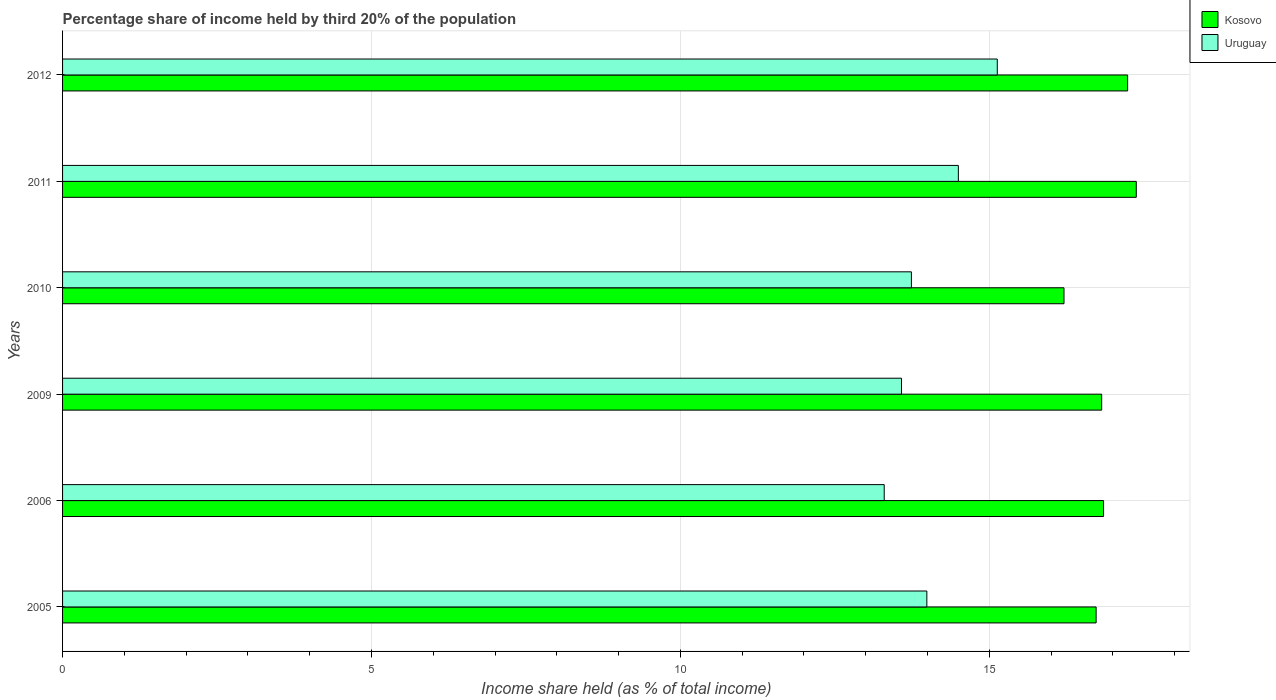How many groups of bars are there?
Provide a short and direct response. 6. Are the number of bars on each tick of the Y-axis equal?
Keep it short and to the point. Yes. How many bars are there on the 4th tick from the top?
Provide a short and direct response. 2. How many bars are there on the 4th tick from the bottom?
Your response must be concise. 2. In how many cases, is the number of bars for a given year not equal to the number of legend labels?
Offer a terse response. 0. Across all years, what is the maximum share of income held by third 20% of the population in Kosovo?
Your answer should be compact. 17.38. Across all years, what is the minimum share of income held by third 20% of the population in Uruguay?
Offer a very short reply. 13.3. In which year was the share of income held by third 20% of the population in Uruguay minimum?
Provide a succinct answer. 2006. What is the total share of income held by third 20% of the population in Uruguay in the graph?
Give a very brief answer. 84.24. What is the difference between the share of income held by third 20% of the population in Kosovo in 2005 and that in 2009?
Your answer should be compact. -0.09. What is the difference between the share of income held by third 20% of the population in Uruguay in 2005 and the share of income held by third 20% of the population in Kosovo in 2012?
Your response must be concise. -3.25. What is the average share of income held by third 20% of the population in Uruguay per year?
Provide a succinct answer. 14.04. In the year 2009, what is the difference between the share of income held by third 20% of the population in Kosovo and share of income held by third 20% of the population in Uruguay?
Provide a succinct answer. 3.24. What is the ratio of the share of income held by third 20% of the population in Uruguay in 2005 to that in 2006?
Provide a short and direct response. 1.05. What is the difference between the highest and the second highest share of income held by third 20% of the population in Kosovo?
Offer a very short reply. 0.14. What is the difference between the highest and the lowest share of income held by third 20% of the population in Uruguay?
Provide a succinct answer. 1.83. Is the sum of the share of income held by third 20% of the population in Kosovo in 2006 and 2011 greater than the maximum share of income held by third 20% of the population in Uruguay across all years?
Your answer should be very brief. Yes. What does the 1st bar from the top in 2005 represents?
Your response must be concise. Uruguay. What does the 1st bar from the bottom in 2006 represents?
Provide a succinct answer. Kosovo. How many bars are there?
Offer a terse response. 12. Are the values on the major ticks of X-axis written in scientific E-notation?
Provide a succinct answer. No. Does the graph contain grids?
Offer a terse response. Yes. How are the legend labels stacked?
Your answer should be very brief. Vertical. What is the title of the graph?
Offer a very short reply. Percentage share of income held by third 20% of the population. Does "High income" appear as one of the legend labels in the graph?
Provide a short and direct response. No. What is the label or title of the X-axis?
Your response must be concise. Income share held (as % of total income). What is the label or title of the Y-axis?
Provide a succinct answer. Years. What is the Income share held (as % of total income) of Kosovo in 2005?
Your answer should be very brief. 16.73. What is the Income share held (as % of total income) in Uruguay in 2005?
Your answer should be very brief. 13.99. What is the Income share held (as % of total income) of Kosovo in 2006?
Give a very brief answer. 16.85. What is the Income share held (as % of total income) in Kosovo in 2009?
Provide a succinct answer. 16.82. What is the Income share held (as % of total income) in Uruguay in 2009?
Give a very brief answer. 13.58. What is the Income share held (as % of total income) of Kosovo in 2010?
Give a very brief answer. 16.21. What is the Income share held (as % of total income) of Uruguay in 2010?
Keep it short and to the point. 13.74. What is the Income share held (as % of total income) of Kosovo in 2011?
Provide a succinct answer. 17.38. What is the Income share held (as % of total income) of Uruguay in 2011?
Provide a succinct answer. 14.5. What is the Income share held (as % of total income) of Kosovo in 2012?
Offer a terse response. 17.24. What is the Income share held (as % of total income) in Uruguay in 2012?
Your answer should be very brief. 15.13. Across all years, what is the maximum Income share held (as % of total income) of Kosovo?
Your answer should be very brief. 17.38. Across all years, what is the maximum Income share held (as % of total income) of Uruguay?
Provide a succinct answer. 15.13. Across all years, what is the minimum Income share held (as % of total income) of Kosovo?
Your response must be concise. 16.21. Across all years, what is the minimum Income share held (as % of total income) in Uruguay?
Ensure brevity in your answer.  13.3. What is the total Income share held (as % of total income) of Kosovo in the graph?
Give a very brief answer. 101.23. What is the total Income share held (as % of total income) of Uruguay in the graph?
Your response must be concise. 84.24. What is the difference between the Income share held (as % of total income) of Kosovo in 2005 and that in 2006?
Make the answer very short. -0.12. What is the difference between the Income share held (as % of total income) of Uruguay in 2005 and that in 2006?
Give a very brief answer. 0.69. What is the difference between the Income share held (as % of total income) of Kosovo in 2005 and that in 2009?
Give a very brief answer. -0.09. What is the difference between the Income share held (as % of total income) of Uruguay in 2005 and that in 2009?
Keep it short and to the point. 0.41. What is the difference between the Income share held (as % of total income) in Kosovo in 2005 and that in 2010?
Give a very brief answer. 0.52. What is the difference between the Income share held (as % of total income) of Uruguay in 2005 and that in 2010?
Offer a terse response. 0.25. What is the difference between the Income share held (as % of total income) in Kosovo in 2005 and that in 2011?
Keep it short and to the point. -0.65. What is the difference between the Income share held (as % of total income) of Uruguay in 2005 and that in 2011?
Offer a terse response. -0.51. What is the difference between the Income share held (as % of total income) of Kosovo in 2005 and that in 2012?
Ensure brevity in your answer.  -0.51. What is the difference between the Income share held (as % of total income) of Uruguay in 2005 and that in 2012?
Keep it short and to the point. -1.14. What is the difference between the Income share held (as % of total income) in Kosovo in 2006 and that in 2009?
Offer a very short reply. 0.03. What is the difference between the Income share held (as % of total income) of Uruguay in 2006 and that in 2009?
Your response must be concise. -0.28. What is the difference between the Income share held (as % of total income) in Kosovo in 2006 and that in 2010?
Provide a succinct answer. 0.64. What is the difference between the Income share held (as % of total income) of Uruguay in 2006 and that in 2010?
Offer a very short reply. -0.44. What is the difference between the Income share held (as % of total income) in Kosovo in 2006 and that in 2011?
Offer a terse response. -0.53. What is the difference between the Income share held (as % of total income) of Uruguay in 2006 and that in 2011?
Make the answer very short. -1.2. What is the difference between the Income share held (as % of total income) in Kosovo in 2006 and that in 2012?
Offer a terse response. -0.39. What is the difference between the Income share held (as % of total income) in Uruguay in 2006 and that in 2012?
Keep it short and to the point. -1.83. What is the difference between the Income share held (as % of total income) in Kosovo in 2009 and that in 2010?
Provide a short and direct response. 0.61. What is the difference between the Income share held (as % of total income) in Uruguay in 2009 and that in 2010?
Your answer should be very brief. -0.16. What is the difference between the Income share held (as % of total income) of Kosovo in 2009 and that in 2011?
Offer a very short reply. -0.56. What is the difference between the Income share held (as % of total income) of Uruguay in 2009 and that in 2011?
Offer a terse response. -0.92. What is the difference between the Income share held (as % of total income) of Kosovo in 2009 and that in 2012?
Your response must be concise. -0.42. What is the difference between the Income share held (as % of total income) of Uruguay in 2009 and that in 2012?
Your response must be concise. -1.55. What is the difference between the Income share held (as % of total income) in Kosovo in 2010 and that in 2011?
Your answer should be very brief. -1.17. What is the difference between the Income share held (as % of total income) of Uruguay in 2010 and that in 2011?
Your response must be concise. -0.76. What is the difference between the Income share held (as % of total income) in Kosovo in 2010 and that in 2012?
Your answer should be very brief. -1.03. What is the difference between the Income share held (as % of total income) in Uruguay in 2010 and that in 2012?
Your answer should be compact. -1.39. What is the difference between the Income share held (as % of total income) in Kosovo in 2011 and that in 2012?
Your response must be concise. 0.14. What is the difference between the Income share held (as % of total income) in Uruguay in 2011 and that in 2012?
Keep it short and to the point. -0.63. What is the difference between the Income share held (as % of total income) in Kosovo in 2005 and the Income share held (as % of total income) in Uruguay in 2006?
Provide a succinct answer. 3.43. What is the difference between the Income share held (as % of total income) of Kosovo in 2005 and the Income share held (as % of total income) of Uruguay in 2009?
Provide a succinct answer. 3.15. What is the difference between the Income share held (as % of total income) in Kosovo in 2005 and the Income share held (as % of total income) in Uruguay in 2010?
Your answer should be very brief. 2.99. What is the difference between the Income share held (as % of total income) of Kosovo in 2005 and the Income share held (as % of total income) of Uruguay in 2011?
Offer a terse response. 2.23. What is the difference between the Income share held (as % of total income) in Kosovo in 2006 and the Income share held (as % of total income) in Uruguay in 2009?
Keep it short and to the point. 3.27. What is the difference between the Income share held (as % of total income) of Kosovo in 2006 and the Income share held (as % of total income) of Uruguay in 2010?
Provide a succinct answer. 3.11. What is the difference between the Income share held (as % of total income) of Kosovo in 2006 and the Income share held (as % of total income) of Uruguay in 2011?
Provide a succinct answer. 2.35. What is the difference between the Income share held (as % of total income) in Kosovo in 2006 and the Income share held (as % of total income) in Uruguay in 2012?
Keep it short and to the point. 1.72. What is the difference between the Income share held (as % of total income) in Kosovo in 2009 and the Income share held (as % of total income) in Uruguay in 2010?
Provide a succinct answer. 3.08. What is the difference between the Income share held (as % of total income) of Kosovo in 2009 and the Income share held (as % of total income) of Uruguay in 2011?
Offer a very short reply. 2.32. What is the difference between the Income share held (as % of total income) of Kosovo in 2009 and the Income share held (as % of total income) of Uruguay in 2012?
Your response must be concise. 1.69. What is the difference between the Income share held (as % of total income) of Kosovo in 2010 and the Income share held (as % of total income) of Uruguay in 2011?
Provide a short and direct response. 1.71. What is the difference between the Income share held (as % of total income) of Kosovo in 2011 and the Income share held (as % of total income) of Uruguay in 2012?
Ensure brevity in your answer.  2.25. What is the average Income share held (as % of total income) of Kosovo per year?
Offer a terse response. 16.87. What is the average Income share held (as % of total income) in Uruguay per year?
Your answer should be very brief. 14.04. In the year 2005, what is the difference between the Income share held (as % of total income) of Kosovo and Income share held (as % of total income) of Uruguay?
Your response must be concise. 2.74. In the year 2006, what is the difference between the Income share held (as % of total income) in Kosovo and Income share held (as % of total income) in Uruguay?
Keep it short and to the point. 3.55. In the year 2009, what is the difference between the Income share held (as % of total income) in Kosovo and Income share held (as % of total income) in Uruguay?
Keep it short and to the point. 3.24. In the year 2010, what is the difference between the Income share held (as % of total income) of Kosovo and Income share held (as % of total income) of Uruguay?
Your answer should be compact. 2.47. In the year 2011, what is the difference between the Income share held (as % of total income) in Kosovo and Income share held (as % of total income) in Uruguay?
Keep it short and to the point. 2.88. In the year 2012, what is the difference between the Income share held (as % of total income) of Kosovo and Income share held (as % of total income) of Uruguay?
Your answer should be compact. 2.11. What is the ratio of the Income share held (as % of total income) of Kosovo in 2005 to that in 2006?
Make the answer very short. 0.99. What is the ratio of the Income share held (as % of total income) in Uruguay in 2005 to that in 2006?
Offer a terse response. 1.05. What is the ratio of the Income share held (as % of total income) of Kosovo in 2005 to that in 2009?
Ensure brevity in your answer.  0.99. What is the ratio of the Income share held (as % of total income) of Uruguay in 2005 to that in 2009?
Keep it short and to the point. 1.03. What is the ratio of the Income share held (as % of total income) in Kosovo in 2005 to that in 2010?
Keep it short and to the point. 1.03. What is the ratio of the Income share held (as % of total income) in Uruguay in 2005 to that in 2010?
Make the answer very short. 1.02. What is the ratio of the Income share held (as % of total income) in Kosovo in 2005 to that in 2011?
Offer a very short reply. 0.96. What is the ratio of the Income share held (as % of total income) in Uruguay in 2005 to that in 2011?
Provide a succinct answer. 0.96. What is the ratio of the Income share held (as % of total income) in Kosovo in 2005 to that in 2012?
Keep it short and to the point. 0.97. What is the ratio of the Income share held (as % of total income) in Uruguay in 2005 to that in 2012?
Offer a terse response. 0.92. What is the ratio of the Income share held (as % of total income) in Uruguay in 2006 to that in 2009?
Keep it short and to the point. 0.98. What is the ratio of the Income share held (as % of total income) in Kosovo in 2006 to that in 2010?
Your answer should be compact. 1.04. What is the ratio of the Income share held (as % of total income) in Uruguay in 2006 to that in 2010?
Your response must be concise. 0.97. What is the ratio of the Income share held (as % of total income) of Kosovo in 2006 to that in 2011?
Provide a succinct answer. 0.97. What is the ratio of the Income share held (as % of total income) in Uruguay in 2006 to that in 2011?
Provide a short and direct response. 0.92. What is the ratio of the Income share held (as % of total income) of Kosovo in 2006 to that in 2012?
Provide a succinct answer. 0.98. What is the ratio of the Income share held (as % of total income) in Uruguay in 2006 to that in 2012?
Your answer should be very brief. 0.88. What is the ratio of the Income share held (as % of total income) of Kosovo in 2009 to that in 2010?
Give a very brief answer. 1.04. What is the ratio of the Income share held (as % of total income) in Uruguay in 2009 to that in 2010?
Keep it short and to the point. 0.99. What is the ratio of the Income share held (as % of total income) of Kosovo in 2009 to that in 2011?
Provide a succinct answer. 0.97. What is the ratio of the Income share held (as % of total income) in Uruguay in 2009 to that in 2011?
Make the answer very short. 0.94. What is the ratio of the Income share held (as % of total income) in Kosovo in 2009 to that in 2012?
Provide a succinct answer. 0.98. What is the ratio of the Income share held (as % of total income) in Uruguay in 2009 to that in 2012?
Your answer should be very brief. 0.9. What is the ratio of the Income share held (as % of total income) in Kosovo in 2010 to that in 2011?
Your answer should be very brief. 0.93. What is the ratio of the Income share held (as % of total income) in Uruguay in 2010 to that in 2011?
Offer a very short reply. 0.95. What is the ratio of the Income share held (as % of total income) of Kosovo in 2010 to that in 2012?
Your answer should be compact. 0.94. What is the ratio of the Income share held (as % of total income) of Uruguay in 2010 to that in 2012?
Ensure brevity in your answer.  0.91. What is the ratio of the Income share held (as % of total income) in Kosovo in 2011 to that in 2012?
Keep it short and to the point. 1.01. What is the ratio of the Income share held (as % of total income) in Uruguay in 2011 to that in 2012?
Give a very brief answer. 0.96. What is the difference between the highest and the second highest Income share held (as % of total income) of Kosovo?
Offer a very short reply. 0.14. What is the difference between the highest and the second highest Income share held (as % of total income) in Uruguay?
Ensure brevity in your answer.  0.63. What is the difference between the highest and the lowest Income share held (as % of total income) in Kosovo?
Ensure brevity in your answer.  1.17. What is the difference between the highest and the lowest Income share held (as % of total income) in Uruguay?
Offer a very short reply. 1.83. 